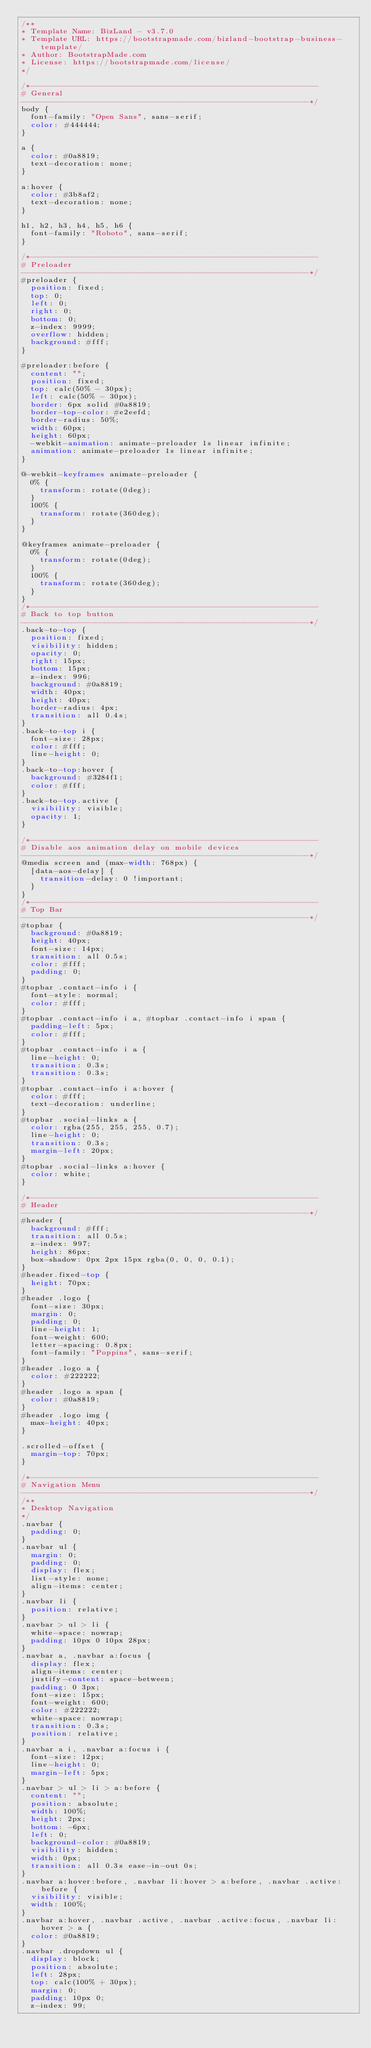Convert code to text. <code><loc_0><loc_0><loc_500><loc_500><_CSS_>/**
* Template Name: BizLand - v3.7.0
* Template URL: https://bootstrapmade.com/bizland-bootstrap-business-template/
* Author: BootstrapMade.com
* License: https://bootstrapmade.com/license/
*/

/*--------------------------------------------------------------
# General
--------------------------------------------------------------*/
body {
  font-family: "Open Sans", sans-serif;
  color: #444444;
}

a {
  color: #0a8819;
  text-decoration: none;
}

a:hover {
  color: #3b8af2;
  text-decoration: none;
}

h1, h2, h3, h4, h5, h6 {
  font-family: "Roboto", sans-serif;
}

/*--------------------------------------------------------------
# Preloader
--------------------------------------------------------------*/
#preloader {
  position: fixed;
  top: 0;
  left: 0;
  right: 0;
  bottom: 0;
  z-index: 9999;
  overflow: hidden;
  background: #fff;
}

#preloader:before {
  content: "";
  position: fixed;
  top: calc(50% - 30px);
  left: calc(50% - 30px);
  border: 6px solid #0a8819;
  border-top-color: #e2eefd;
  border-radius: 50%;
  width: 60px;
  height: 60px;
  -webkit-animation: animate-preloader 1s linear infinite;
  animation: animate-preloader 1s linear infinite;
}

@-webkit-keyframes animate-preloader {
  0% {
    transform: rotate(0deg);
  }
  100% {
    transform: rotate(360deg);
  }
}

@keyframes animate-preloader {
  0% {
    transform: rotate(0deg);
  }
  100% {
    transform: rotate(360deg);
  }
}
/*--------------------------------------------------------------
# Back to top button
--------------------------------------------------------------*/
.back-to-top {
  position: fixed;
  visibility: hidden;
  opacity: 0;
  right: 15px;
  bottom: 15px;
  z-index: 996;
  background: #0a8819;
  width: 40px;
  height: 40px;
  border-radius: 4px;
  transition: all 0.4s;
}
.back-to-top i {
  font-size: 28px;
  color: #fff;
  line-height: 0;
}
.back-to-top:hover {
  background: #3284f1;
  color: #fff;
}
.back-to-top.active {
  visibility: visible;
  opacity: 1;
}

/*--------------------------------------------------------------
# Disable aos animation delay on mobile devices
--------------------------------------------------------------*/
@media screen and (max-width: 768px) {
  [data-aos-delay] {
    transition-delay: 0 !important;
  }
}
/*--------------------------------------------------------------
# Top Bar
--------------------------------------------------------------*/
#topbar {
  background: #0a8819;
  height: 40px;
  font-size: 14px;
  transition: all 0.5s;
  color: #fff;
  padding: 0;
}
#topbar .contact-info i {
  font-style: normal;
  color: #fff;
}
#topbar .contact-info i a, #topbar .contact-info i span {
  padding-left: 5px;
  color: #fff;
}
#topbar .contact-info i a {
  line-height: 0;
  transition: 0.3s;
  transition: 0.3s;
}
#topbar .contact-info i a:hover {
  color: #fff;
  text-decoration: underline;
}
#topbar .social-links a {
  color: rgba(255, 255, 255, 0.7);
  line-height: 0;
  transition: 0.3s;
  margin-left: 20px;
}
#topbar .social-links a:hover {
  color: white;
}

/*--------------------------------------------------------------
# Header
--------------------------------------------------------------*/
#header {
  background: #fff;
  transition: all 0.5s;
  z-index: 997;
  height: 86px;
  box-shadow: 0px 2px 15px rgba(0, 0, 0, 0.1);
}
#header.fixed-top {
  height: 70px;
}
#header .logo {
  font-size: 30px;
  margin: 0;
  padding: 0;
  line-height: 1;
  font-weight: 600;
  letter-spacing: 0.8px;
  font-family: "Poppins", sans-serif;
}
#header .logo a {
  color: #222222;
}
#header .logo a span {
  color: #0a8819;
}
#header .logo img {
  max-height: 40px;
}

.scrolled-offset {
  margin-top: 70px;
}

/*--------------------------------------------------------------
# Navigation Menu
--------------------------------------------------------------*/
/**
* Desktop Navigation 
*/
.navbar {
  padding: 0;
}
.navbar ul {
  margin: 0;
  padding: 0;
  display: flex;
  list-style: none;
  align-items: center;
}
.navbar li {
  position: relative;
}
.navbar > ul > li {
  white-space: nowrap;
  padding: 10px 0 10px 28px;
}
.navbar a, .navbar a:focus {
  display: flex;
  align-items: center;
  justify-content: space-between;
  padding: 0 3px;
  font-size: 15px;
  font-weight: 600;
  color: #222222;
  white-space: nowrap;
  transition: 0.3s;
  position: relative;
}
.navbar a i, .navbar a:focus i {
  font-size: 12px;
  line-height: 0;
  margin-left: 5px;
}
.navbar > ul > li > a:before {
  content: "";
  position: absolute;
  width: 100%;
  height: 2px;
  bottom: -6px;
  left: 0;
  background-color: #0a8819;
  visibility: hidden;
  width: 0px;
  transition: all 0.3s ease-in-out 0s;
}
.navbar a:hover:before, .navbar li:hover > a:before, .navbar .active:before {
  visibility: visible;
  width: 100%;
}
.navbar a:hover, .navbar .active, .navbar .active:focus, .navbar li:hover > a {
  color: #0a8819;
}
.navbar .dropdown ul {
  display: block;
  position: absolute;
  left: 28px;
  top: calc(100% + 30px);
  margin: 0;
  padding: 10px 0;
  z-index: 99;</code> 